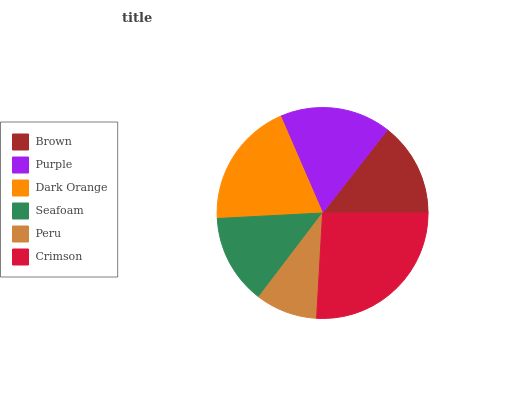Is Peru the minimum?
Answer yes or no. Yes. Is Crimson the maximum?
Answer yes or no. Yes. Is Purple the minimum?
Answer yes or no. No. Is Purple the maximum?
Answer yes or no. No. Is Purple greater than Brown?
Answer yes or no. Yes. Is Brown less than Purple?
Answer yes or no. Yes. Is Brown greater than Purple?
Answer yes or no. No. Is Purple less than Brown?
Answer yes or no. No. Is Purple the high median?
Answer yes or no. Yes. Is Brown the low median?
Answer yes or no. Yes. Is Brown the high median?
Answer yes or no. No. Is Purple the low median?
Answer yes or no. No. 